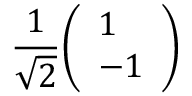<formula> <loc_0><loc_0><loc_500><loc_500>{ \frac { 1 } { \sqrt { 2 } } } { \left ( \begin{array} { l } { 1 } \\ { - 1 } \end{array} \right ) }</formula> 